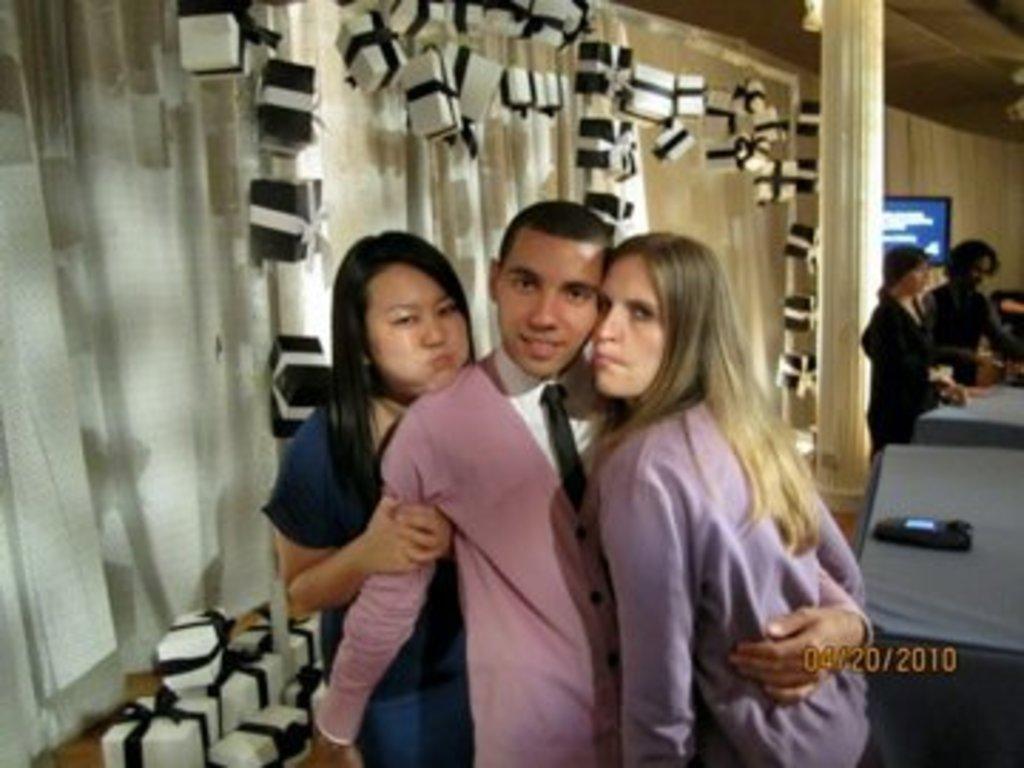How would you summarize this image in a sentence or two? In this picture, we can see a few people, and we can see the table with some device on it, we can see the wall with curtain, and some objects attached to it, we can see pillar, screen and some objects in the bottom left corner, we can see the date on bottom right corner. 